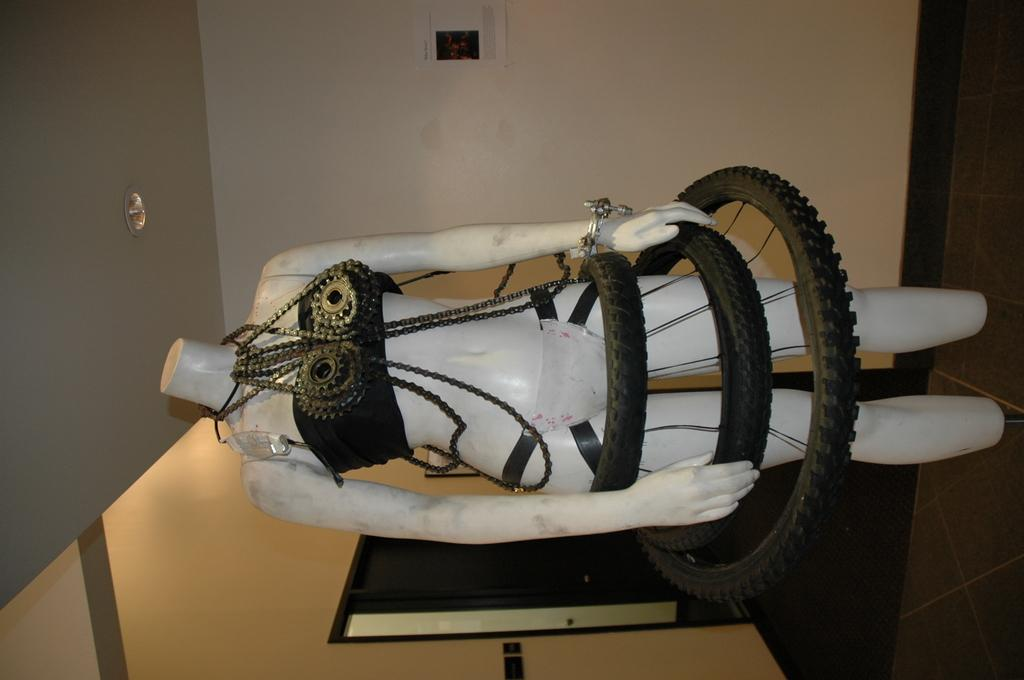What is the main object in the image? There is a white color mannequin in the image. What other items can be seen in the image? A cycle chain and three black vehicle tires are visible in the image. What can be seen in the background of the image? There is a wall and a door in the background of the image. How many dust particles can be seen on the mannequin in the image? There is no mention of dust particles in the image, so it is not possible to determine their number. 